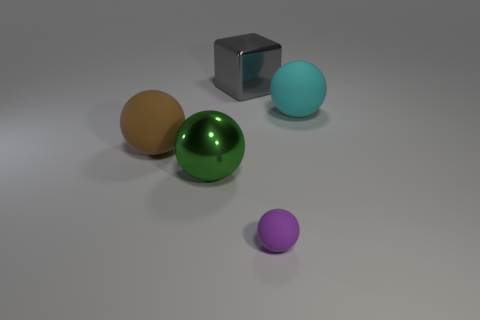Subtract all metal balls. How many balls are left? 3 Add 2 small things. How many objects exist? 7 Subtract all cyan balls. How many balls are left? 3 Subtract all gray spheres. Subtract all brown blocks. How many spheres are left? 4 Subtract 0 gray balls. How many objects are left? 5 Subtract all cubes. How many objects are left? 4 Subtract all large cubes. Subtract all big green metallic spheres. How many objects are left? 3 Add 1 cyan things. How many cyan things are left? 2 Add 3 purple rubber objects. How many purple rubber objects exist? 4 